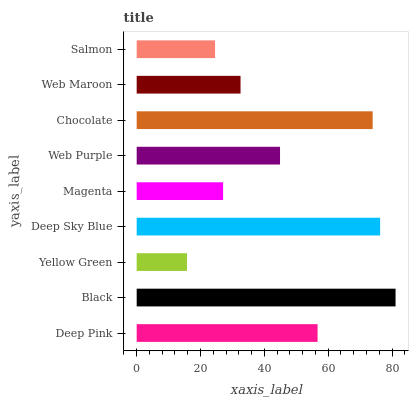Is Yellow Green the minimum?
Answer yes or no. Yes. Is Black the maximum?
Answer yes or no. Yes. Is Black the minimum?
Answer yes or no. No. Is Yellow Green the maximum?
Answer yes or no. No. Is Black greater than Yellow Green?
Answer yes or no. Yes. Is Yellow Green less than Black?
Answer yes or no. Yes. Is Yellow Green greater than Black?
Answer yes or no. No. Is Black less than Yellow Green?
Answer yes or no. No. Is Web Purple the high median?
Answer yes or no. Yes. Is Web Purple the low median?
Answer yes or no. Yes. Is Magenta the high median?
Answer yes or no. No. Is Deep Sky Blue the low median?
Answer yes or no. No. 